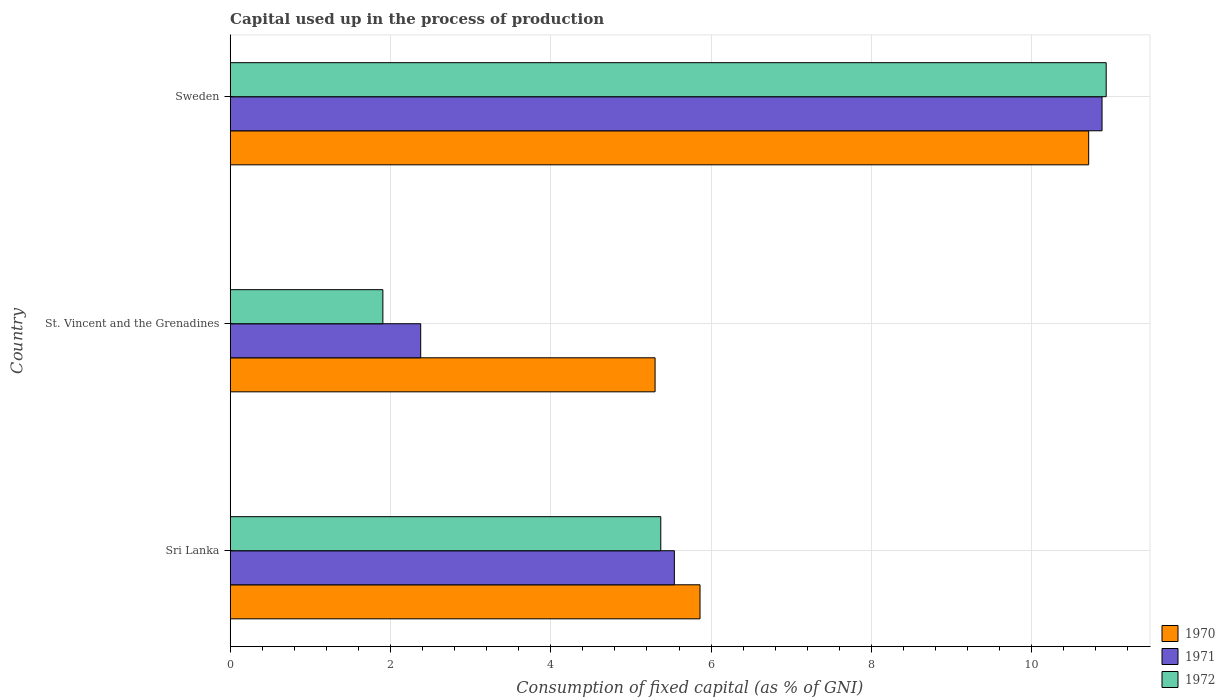How many different coloured bars are there?
Your response must be concise. 3. How many groups of bars are there?
Your answer should be compact. 3. Are the number of bars on each tick of the Y-axis equal?
Your answer should be very brief. Yes. What is the capital used up in the process of production in 1971 in St. Vincent and the Grenadines?
Give a very brief answer. 2.38. Across all countries, what is the maximum capital used up in the process of production in 1971?
Your response must be concise. 10.88. Across all countries, what is the minimum capital used up in the process of production in 1971?
Provide a short and direct response. 2.38. In which country was the capital used up in the process of production in 1971 minimum?
Your answer should be very brief. St. Vincent and the Grenadines. What is the total capital used up in the process of production in 1972 in the graph?
Provide a short and direct response. 18.21. What is the difference between the capital used up in the process of production in 1970 in Sri Lanka and that in St. Vincent and the Grenadines?
Provide a succinct answer. 0.56. What is the difference between the capital used up in the process of production in 1971 in Sri Lanka and the capital used up in the process of production in 1972 in St. Vincent and the Grenadines?
Ensure brevity in your answer.  3.64. What is the average capital used up in the process of production in 1972 per country?
Offer a terse response. 6.07. What is the difference between the capital used up in the process of production in 1972 and capital used up in the process of production in 1971 in Sweden?
Give a very brief answer. 0.05. What is the ratio of the capital used up in the process of production in 1970 in St. Vincent and the Grenadines to that in Sweden?
Provide a succinct answer. 0.49. Is the capital used up in the process of production in 1971 in Sri Lanka less than that in Sweden?
Provide a succinct answer. Yes. Is the difference between the capital used up in the process of production in 1972 in Sri Lanka and Sweden greater than the difference between the capital used up in the process of production in 1971 in Sri Lanka and Sweden?
Provide a short and direct response. No. What is the difference between the highest and the second highest capital used up in the process of production in 1972?
Keep it short and to the point. 5.56. What is the difference between the highest and the lowest capital used up in the process of production in 1972?
Ensure brevity in your answer.  9.02. In how many countries, is the capital used up in the process of production in 1972 greater than the average capital used up in the process of production in 1972 taken over all countries?
Provide a short and direct response. 1. What does the 2nd bar from the bottom in Sri Lanka represents?
Your answer should be compact. 1971. How many bars are there?
Offer a very short reply. 9. Are all the bars in the graph horizontal?
Your response must be concise. Yes. How many countries are there in the graph?
Provide a short and direct response. 3. What is the difference between two consecutive major ticks on the X-axis?
Your response must be concise. 2. Are the values on the major ticks of X-axis written in scientific E-notation?
Offer a terse response. No. Does the graph contain any zero values?
Make the answer very short. No. Does the graph contain grids?
Your answer should be compact. Yes. What is the title of the graph?
Offer a terse response. Capital used up in the process of production. Does "1994" appear as one of the legend labels in the graph?
Your answer should be compact. No. What is the label or title of the X-axis?
Ensure brevity in your answer.  Consumption of fixed capital (as % of GNI). What is the Consumption of fixed capital (as % of GNI) in 1970 in Sri Lanka?
Your answer should be compact. 5.86. What is the Consumption of fixed capital (as % of GNI) of 1971 in Sri Lanka?
Give a very brief answer. 5.54. What is the Consumption of fixed capital (as % of GNI) of 1972 in Sri Lanka?
Your response must be concise. 5.37. What is the Consumption of fixed capital (as % of GNI) of 1970 in St. Vincent and the Grenadines?
Keep it short and to the point. 5.3. What is the Consumption of fixed capital (as % of GNI) in 1971 in St. Vincent and the Grenadines?
Make the answer very short. 2.38. What is the Consumption of fixed capital (as % of GNI) of 1972 in St. Vincent and the Grenadines?
Give a very brief answer. 1.9. What is the Consumption of fixed capital (as % of GNI) in 1970 in Sweden?
Your answer should be very brief. 10.71. What is the Consumption of fixed capital (as % of GNI) of 1971 in Sweden?
Keep it short and to the point. 10.88. What is the Consumption of fixed capital (as % of GNI) in 1972 in Sweden?
Ensure brevity in your answer.  10.93. Across all countries, what is the maximum Consumption of fixed capital (as % of GNI) of 1970?
Offer a terse response. 10.71. Across all countries, what is the maximum Consumption of fixed capital (as % of GNI) in 1971?
Your answer should be very brief. 10.88. Across all countries, what is the maximum Consumption of fixed capital (as % of GNI) in 1972?
Keep it short and to the point. 10.93. Across all countries, what is the minimum Consumption of fixed capital (as % of GNI) of 1970?
Make the answer very short. 5.3. Across all countries, what is the minimum Consumption of fixed capital (as % of GNI) of 1971?
Your answer should be compact. 2.38. Across all countries, what is the minimum Consumption of fixed capital (as % of GNI) of 1972?
Provide a succinct answer. 1.9. What is the total Consumption of fixed capital (as % of GNI) of 1970 in the graph?
Ensure brevity in your answer.  21.87. What is the total Consumption of fixed capital (as % of GNI) of 1971 in the graph?
Make the answer very short. 18.8. What is the total Consumption of fixed capital (as % of GNI) of 1972 in the graph?
Offer a terse response. 18.21. What is the difference between the Consumption of fixed capital (as % of GNI) in 1970 in Sri Lanka and that in St. Vincent and the Grenadines?
Provide a succinct answer. 0.56. What is the difference between the Consumption of fixed capital (as % of GNI) in 1971 in Sri Lanka and that in St. Vincent and the Grenadines?
Your answer should be very brief. 3.16. What is the difference between the Consumption of fixed capital (as % of GNI) in 1972 in Sri Lanka and that in St. Vincent and the Grenadines?
Keep it short and to the point. 3.47. What is the difference between the Consumption of fixed capital (as % of GNI) in 1970 in Sri Lanka and that in Sweden?
Offer a very short reply. -4.85. What is the difference between the Consumption of fixed capital (as % of GNI) in 1971 in Sri Lanka and that in Sweden?
Provide a succinct answer. -5.34. What is the difference between the Consumption of fixed capital (as % of GNI) of 1972 in Sri Lanka and that in Sweden?
Make the answer very short. -5.56. What is the difference between the Consumption of fixed capital (as % of GNI) in 1970 in St. Vincent and the Grenadines and that in Sweden?
Your response must be concise. -5.41. What is the difference between the Consumption of fixed capital (as % of GNI) of 1971 in St. Vincent and the Grenadines and that in Sweden?
Provide a short and direct response. -8.5. What is the difference between the Consumption of fixed capital (as % of GNI) of 1972 in St. Vincent and the Grenadines and that in Sweden?
Make the answer very short. -9.02. What is the difference between the Consumption of fixed capital (as % of GNI) of 1970 in Sri Lanka and the Consumption of fixed capital (as % of GNI) of 1971 in St. Vincent and the Grenadines?
Your answer should be very brief. 3.48. What is the difference between the Consumption of fixed capital (as % of GNI) in 1970 in Sri Lanka and the Consumption of fixed capital (as % of GNI) in 1972 in St. Vincent and the Grenadines?
Keep it short and to the point. 3.96. What is the difference between the Consumption of fixed capital (as % of GNI) of 1971 in Sri Lanka and the Consumption of fixed capital (as % of GNI) of 1972 in St. Vincent and the Grenadines?
Your response must be concise. 3.64. What is the difference between the Consumption of fixed capital (as % of GNI) of 1970 in Sri Lanka and the Consumption of fixed capital (as % of GNI) of 1971 in Sweden?
Offer a very short reply. -5.02. What is the difference between the Consumption of fixed capital (as % of GNI) of 1970 in Sri Lanka and the Consumption of fixed capital (as % of GNI) of 1972 in Sweden?
Make the answer very short. -5.07. What is the difference between the Consumption of fixed capital (as % of GNI) in 1971 in Sri Lanka and the Consumption of fixed capital (as % of GNI) in 1972 in Sweden?
Provide a short and direct response. -5.39. What is the difference between the Consumption of fixed capital (as % of GNI) in 1970 in St. Vincent and the Grenadines and the Consumption of fixed capital (as % of GNI) in 1971 in Sweden?
Offer a very short reply. -5.58. What is the difference between the Consumption of fixed capital (as % of GNI) of 1970 in St. Vincent and the Grenadines and the Consumption of fixed capital (as % of GNI) of 1972 in Sweden?
Offer a terse response. -5.63. What is the difference between the Consumption of fixed capital (as % of GNI) in 1971 in St. Vincent and the Grenadines and the Consumption of fixed capital (as % of GNI) in 1972 in Sweden?
Offer a terse response. -8.55. What is the average Consumption of fixed capital (as % of GNI) of 1970 per country?
Keep it short and to the point. 7.29. What is the average Consumption of fixed capital (as % of GNI) in 1971 per country?
Keep it short and to the point. 6.27. What is the average Consumption of fixed capital (as % of GNI) in 1972 per country?
Ensure brevity in your answer.  6.07. What is the difference between the Consumption of fixed capital (as % of GNI) in 1970 and Consumption of fixed capital (as % of GNI) in 1971 in Sri Lanka?
Give a very brief answer. 0.32. What is the difference between the Consumption of fixed capital (as % of GNI) in 1970 and Consumption of fixed capital (as % of GNI) in 1972 in Sri Lanka?
Ensure brevity in your answer.  0.49. What is the difference between the Consumption of fixed capital (as % of GNI) of 1971 and Consumption of fixed capital (as % of GNI) of 1972 in Sri Lanka?
Give a very brief answer. 0.17. What is the difference between the Consumption of fixed capital (as % of GNI) of 1970 and Consumption of fixed capital (as % of GNI) of 1971 in St. Vincent and the Grenadines?
Your answer should be compact. 2.92. What is the difference between the Consumption of fixed capital (as % of GNI) of 1970 and Consumption of fixed capital (as % of GNI) of 1972 in St. Vincent and the Grenadines?
Your answer should be very brief. 3.4. What is the difference between the Consumption of fixed capital (as % of GNI) in 1971 and Consumption of fixed capital (as % of GNI) in 1972 in St. Vincent and the Grenadines?
Your answer should be compact. 0.47. What is the difference between the Consumption of fixed capital (as % of GNI) of 1970 and Consumption of fixed capital (as % of GNI) of 1971 in Sweden?
Keep it short and to the point. -0.17. What is the difference between the Consumption of fixed capital (as % of GNI) of 1970 and Consumption of fixed capital (as % of GNI) of 1972 in Sweden?
Provide a succinct answer. -0.22. What is the difference between the Consumption of fixed capital (as % of GNI) in 1971 and Consumption of fixed capital (as % of GNI) in 1972 in Sweden?
Your answer should be very brief. -0.05. What is the ratio of the Consumption of fixed capital (as % of GNI) of 1970 in Sri Lanka to that in St. Vincent and the Grenadines?
Your answer should be very brief. 1.11. What is the ratio of the Consumption of fixed capital (as % of GNI) of 1971 in Sri Lanka to that in St. Vincent and the Grenadines?
Your answer should be very brief. 2.33. What is the ratio of the Consumption of fixed capital (as % of GNI) of 1972 in Sri Lanka to that in St. Vincent and the Grenadines?
Your answer should be compact. 2.82. What is the ratio of the Consumption of fixed capital (as % of GNI) in 1970 in Sri Lanka to that in Sweden?
Your answer should be compact. 0.55. What is the ratio of the Consumption of fixed capital (as % of GNI) of 1971 in Sri Lanka to that in Sweden?
Provide a short and direct response. 0.51. What is the ratio of the Consumption of fixed capital (as % of GNI) in 1972 in Sri Lanka to that in Sweden?
Ensure brevity in your answer.  0.49. What is the ratio of the Consumption of fixed capital (as % of GNI) of 1970 in St. Vincent and the Grenadines to that in Sweden?
Make the answer very short. 0.49. What is the ratio of the Consumption of fixed capital (as % of GNI) of 1971 in St. Vincent and the Grenadines to that in Sweden?
Offer a terse response. 0.22. What is the ratio of the Consumption of fixed capital (as % of GNI) of 1972 in St. Vincent and the Grenadines to that in Sweden?
Keep it short and to the point. 0.17. What is the difference between the highest and the second highest Consumption of fixed capital (as % of GNI) of 1970?
Keep it short and to the point. 4.85. What is the difference between the highest and the second highest Consumption of fixed capital (as % of GNI) of 1971?
Ensure brevity in your answer.  5.34. What is the difference between the highest and the second highest Consumption of fixed capital (as % of GNI) in 1972?
Give a very brief answer. 5.56. What is the difference between the highest and the lowest Consumption of fixed capital (as % of GNI) in 1970?
Your response must be concise. 5.41. What is the difference between the highest and the lowest Consumption of fixed capital (as % of GNI) in 1971?
Keep it short and to the point. 8.5. What is the difference between the highest and the lowest Consumption of fixed capital (as % of GNI) of 1972?
Your response must be concise. 9.02. 